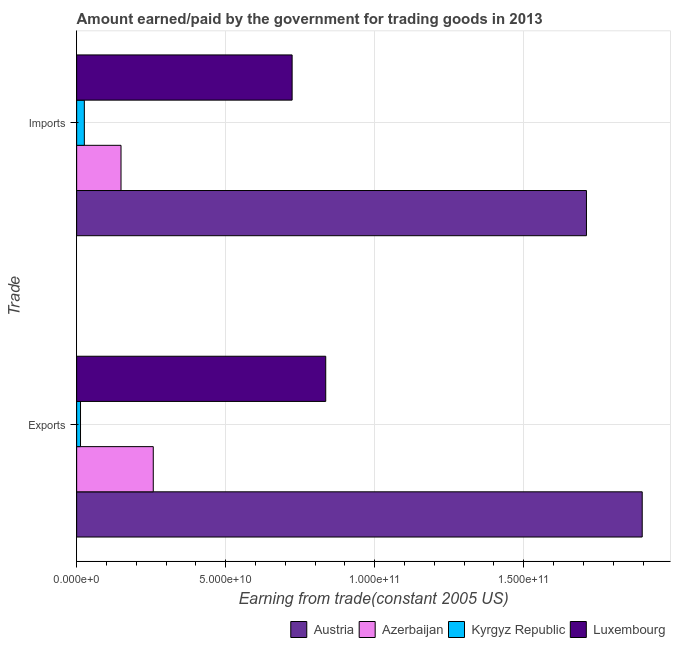How many different coloured bars are there?
Provide a succinct answer. 4. How many groups of bars are there?
Ensure brevity in your answer.  2. Are the number of bars per tick equal to the number of legend labels?
Provide a succinct answer. Yes. How many bars are there on the 2nd tick from the bottom?
Keep it short and to the point. 4. What is the label of the 1st group of bars from the top?
Make the answer very short. Imports. What is the amount paid for imports in Kyrgyz Republic?
Keep it short and to the point. 2.58e+09. Across all countries, what is the maximum amount earned from exports?
Your answer should be very brief. 1.90e+11. Across all countries, what is the minimum amount paid for imports?
Keep it short and to the point. 2.58e+09. In which country was the amount paid for imports minimum?
Offer a very short reply. Kyrgyz Republic. What is the total amount earned from exports in the graph?
Offer a very short reply. 3.00e+11. What is the difference between the amount earned from exports in Austria and that in Kyrgyz Republic?
Your answer should be compact. 1.88e+11. What is the difference between the amount earned from exports in Azerbaijan and the amount paid for imports in Luxembourg?
Make the answer very short. -4.66e+1. What is the average amount earned from exports per country?
Offer a very short reply. 7.51e+1. What is the difference between the amount earned from exports and amount paid for imports in Austria?
Give a very brief answer. 1.87e+1. In how many countries, is the amount paid for imports greater than 140000000000 US$?
Your answer should be compact. 1. What is the ratio of the amount paid for imports in Luxembourg to that in Azerbaijan?
Your answer should be very brief. 4.86. In how many countries, is the amount paid for imports greater than the average amount paid for imports taken over all countries?
Offer a terse response. 2. What does the 2nd bar from the top in Exports represents?
Keep it short and to the point. Kyrgyz Republic. What does the 3rd bar from the bottom in Imports represents?
Make the answer very short. Kyrgyz Republic. How many bars are there?
Your response must be concise. 8. Are all the bars in the graph horizontal?
Your answer should be very brief. Yes. Are the values on the major ticks of X-axis written in scientific E-notation?
Offer a terse response. Yes. How are the legend labels stacked?
Provide a succinct answer. Horizontal. What is the title of the graph?
Provide a succinct answer. Amount earned/paid by the government for trading goods in 2013. What is the label or title of the X-axis?
Ensure brevity in your answer.  Earning from trade(constant 2005 US). What is the label or title of the Y-axis?
Keep it short and to the point. Trade. What is the Earning from trade(constant 2005 US) in Austria in Exports?
Keep it short and to the point. 1.90e+11. What is the Earning from trade(constant 2005 US) of Azerbaijan in Exports?
Offer a very short reply. 2.57e+1. What is the Earning from trade(constant 2005 US) of Kyrgyz Republic in Exports?
Your answer should be compact. 1.29e+09. What is the Earning from trade(constant 2005 US) in Luxembourg in Exports?
Your response must be concise. 8.36e+1. What is the Earning from trade(constant 2005 US) in Austria in Imports?
Provide a short and direct response. 1.71e+11. What is the Earning from trade(constant 2005 US) of Azerbaijan in Imports?
Keep it short and to the point. 1.49e+1. What is the Earning from trade(constant 2005 US) of Kyrgyz Republic in Imports?
Give a very brief answer. 2.58e+09. What is the Earning from trade(constant 2005 US) of Luxembourg in Imports?
Your response must be concise. 7.23e+1. Across all Trade, what is the maximum Earning from trade(constant 2005 US) of Austria?
Your answer should be compact. 1.90e+11. Across all Trade, what is the maximum Earning from trade(constant 2005 US) of Azerbaijan?
Your answer should be very brief. 2.57e+1. Across all Trade, what is the maximum Earning from trade(constant 2005 US) in Kyrgyz Republic?
Offer a very short reply. 2.58e+09. Across all Trade, what is the maximum Earning from trade(constant 2005 US) in Luxembourg?
Offer a terse response. 8.36e+1. Across all Trade, what is the minimum Earning from trade(constant 2005 US) in Austria?
Your answer should be compact. 1.71e+11. Across all Trade, what is the minimum Earning from trade(constant 2005 US) in Azerbaijan?
Your response must be concise. 1.49e+1. Across all Trade, what is the minimum Earning from trade(constant 2005 US) in Kyrgyz Republic?
Keep it short and to the point. 1.29e+09. Across all Trade, what is the minimum Earning from trade(constant 2005 US) in Luxembourg?
Provide a succinct answer. 7.23e+1. What is the total Earning from trade(constant 2005 US) in Austria in the graph?
Provide a short and direct response. 3.61e+11. What is the total Earning from trade(constant 2005 US) of Azerbaijan in the graph?
Ensure brevity in your answer.  4.06e+1. What is the total Earning from trade(constant 2005 US) in Kyrgyz Republic in the graph?
Offer a very short reply. 3.87e+09. What is the total Earning from trade(constant 2005 US) in Luxembourg in the graph?
Your answer should be very brief. 1.56e+11. What is the difference between the Earning from trade(constant 2005 US) of Austria in Exports and that in Imports?
Your response must be concise. 1.87e+1. What is the difference between the Earning from trade(constant 2005 US) in Azerbaijan in Exports and that in Imports?
Give a very brief answer. 1.08e+1. What is the difference between the Earning from trade(constant 2005 US) in Kyrgyz Republic in Exports and that in Imports?
Keep it short and to the point. -1.29e+09. What is the difference between the Earning from trade(constant 2005 US) in Luxembourg in Exports and that in Imports?
Give a very brief answer. 1.13e+1. What is the difference between the Earning from trade(constant 2005 US) of Austria in Exports and the Earning from trade(constant 2005 US) of Azerbaijan in Imports?
Your answer should be compact. 1.75e+11. What is the difference between the Earning from trade(constant 2005 US) of Austria in Exports and the Earning from trade(constant 2005 US) of Kyrgyz Republic in Imports?
Provide a short and direct response. 1.87e+11. What is the difference between the Earning from trade(constant 2005 US) in Austria in Exports and the Earning from trade(constant 2005 US) in Luxembourg in Imports?
Give a very brief answer. 1.17e+11. What is the difference between the Earning from trade(constant 2005 US) of Azerbaijan in Exports and the Earning from trade(constant 2005 US) of Kyrgyz Republic in Imports?
Provide a short and direct response. 2.31e+1. What is the difference between the Earning from trade(constant 2005 US) of Azerbaijan in Exports and the Earning from trade(constant 2005 US) of Luxembourg in Imports?
Offer a very short reply. -4.66e+1. What is the difference between the Earning from trade(constant 2005 US) of Kyrgyz Republic in Exports and the Earning from trade(constant 2005 US) of Luxembourg in Imports?
Offer a very short reply. -7.10e+1. What is the average Earning from trade(constant 2005 US) in Austria per Trade?
Offer a very short reply. 1.80e+11. What is the average Earning from trade(constant 2005 US) in Azerbaijan per Trade?
Keep it short and to the point. 2.03e+1. What is the average Earning from trade(constant 2005 US) of Kyrgyz Republic per Trade?
Your response must be concise. 1.94e+09. What is the average Earning from trade(constant 2005 US) of Luxembourg per Trade?
Ensure brevity in your answer.  7.79e+1. What is the difference between the Earning from trade(constant 2005 US) of Austria and Earning from trade(constant 2005 US) of Azerbaijan in Exports?
Provide a short and direct response. 1.64e+11. What is the difference between the Earning from trade(constant 2005 US) in Austria and Earning from trade(constant 2005 US) in Kyrgyz Republic in Exports?
Give a very brief answer. 1.88e+11. What is the difference between the Earning from trade(constant 2005 US) of Austria and Earning from trade(constant 2005 US) of Luxembourg in Exports?
Ensure brevity in your answer.  1.06e+11. What is the difference between the Earning from trade(constant 2005 US) in Azerbaijan and Earning from trade(constant 2005 US) in Kyrgyz Republic in Exports?
Ensure brevity in your answer.  2.44e+1. What is the difference between the Earning from trade(constant 2005 US) in Azerbaijan and Earning from trade(constant 2005 US) in Luxembourg in Exports?
Offer a terse response. -5.79e+1. What is the difference between the Earning from trade(constant 2005 US) in Kyrgyz Republic and Earning from trade(constant 2005 US) in Luxembourg in Exports?
Provide a succinct answer. -8.23e+1. What is the difference between the Earning from trade(constant 2005 US) in Austria and Earning from trade(constant 2005 US) in Azerbaijan in Imports?
Offer a terse response. 1.56e+11. What is the difference between the Earning from trade(constant 2005 US) of Austria and Earning from trade(constant 2005 US) of Kyrgyz Republic in Imports?
Make the answer very short. 1.68e+11. What is the difference between the Earning from trade(constant 2005 US) in Austria and Earning from trade(constant 2005 US) in Luxembourg in Imports?
Your answer should be very brief. 9.87e+1. What is the difference between the Earning from trade(constant 2005 US) of Azerbaijan and Earning from trade(constant 2005 US) of Kyrgyz Republic in Imports?
Ensure brevity in your answer.  1.23e+1. What is the difference between the Earning from trade(constant 2005 US) in Azerbaijan and Earning from trade(constant 2005 US) in Luxembourg in Imports?
Give a very brief answer. -5.74e+1. What is the difference between the Earning from trade(constant 2005 US) in Kyrgyz Republic and Earning from trade(constant 2005 US) in Luxembourg in Imports?
Your answer should be very brief. -6.97e+1. What is the ratio of the Earning from trade(constant 2005 US) in Austria in Exports to that in Imports?
Give a very brief answer. 1.11. What is the ratio of the Earning from trade(constant 2005 US) of Azerbaijan in Exports to that in Imports?
Give a very brief answer. 1.73. What is the ratio of the Earning from trade(constant 2005 US) of Kyrgyz Republic in Exports to that in Imports?
Offer a very short reply. 0.5. What is the ratio of the Earning from trade(constant 2005 US) of Luxembourg in Exports to that in Imports?
Give a very brief answer. 1.16. What is the difference between the highest and the second highest Earning from trade(constant 2005 US) of Austria?
Provide a succinct answer. 1.87e+1. What is the difference between the highest and the second highest Earning from trade(constant 2005 US) of Azerbaijan?
Make the answer very short. 1.08e+1. What is the difference between the highest and the second highest Earning from trade(constant 2005 US) of Kyrgyz Republic?
Make the answer very short. 1.29e+09. What is the difference between the highest and the second highest Earning from trade(constant 2005 US) of Luxembourg?
Your response must be concise. 1.13e+1. What is the difference between the highest and the lowest Earning from trade(constant 2005 US) of Austria?
Offer a very short reply. 1.87e+1. What is the difference between the highest and the lowest Earning from trade(constant 2005 US) of Azerbaijan?
Ensure brevity in your answer.  1.08e+1. What is the difference between the highest and the lowest Earning from trade(constant 2005 US) in Kyrgyz Republic?
Your answer should be compact. 1.29e+09. What is the difference between the highest and the lowest Earning from trade(constant 2005 US) in Luxembourg?
Ensure brevity in your answer.  1.13e+1. 